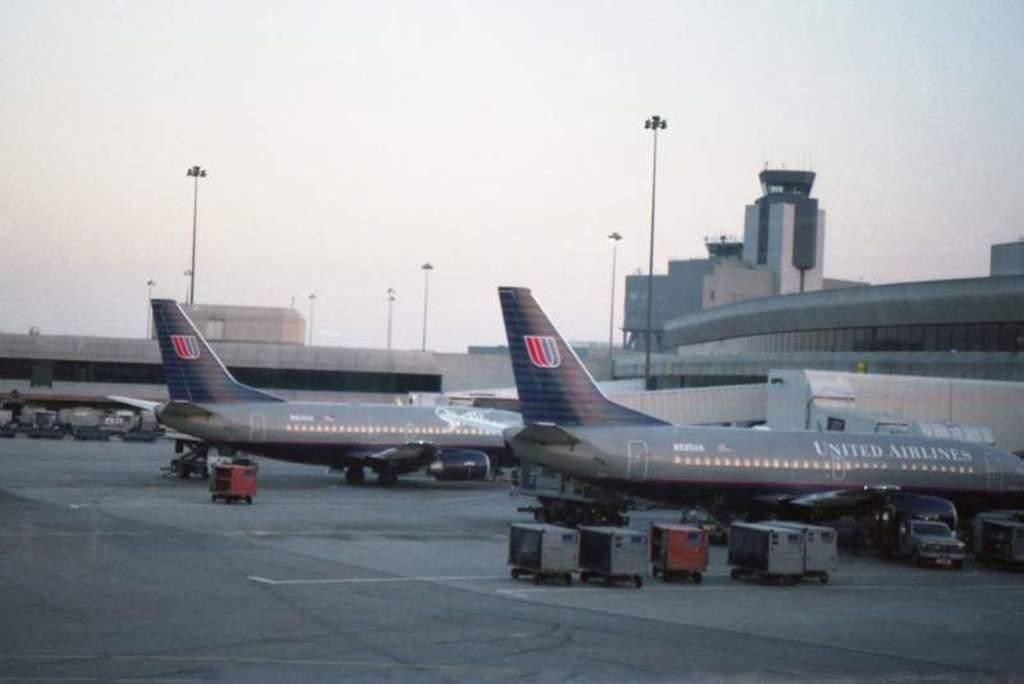Where was the image taken? The image was taken at an airport. What can be seen at the airport in the image? There are aeroplanes at the terminals in the image. What is visible in the background of the image? There is a building and poles in the background of the image, as well as the sky. How many beggars can be seen in the image? There are no beggars present in the image. What type of light is illuminating the aeroplanes in the image? The image does not provide information about the type of light illuminating the aeroplanes; it only shows the aeroplanes at the terminals. 